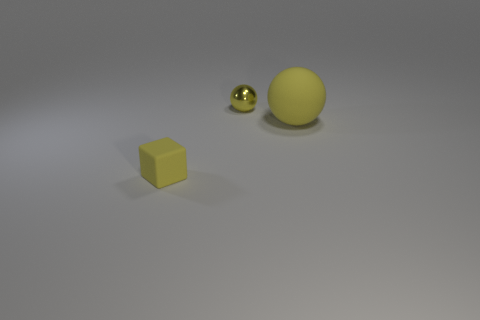What material is the small block that is the same color as the big rubber thing?
Your answer should be very brief. Rubber. What size is the matte sphere that is the same color as the tiny matte block?
Offer a terse response. Large. Is there a tiny yellow object that is to the right of the thing that is on the left side of the tiny sphere?
Provide a short and direct response. Yes. How many things are yellow things right of the matte block or tiny yellow things in front of the shiny thing?
Your response must be concise. 3. Is there any other thing that has the same color as the shiny sphere?
Ensure brevity in your answer.  Yes. There is a rubber object on the right side of the ball that is to the left of the rubber object behind the small matte thing; what color is it?
Ensure brevity in your answer.  Yellow. There is a yellow object that is to the right of the tiny object behind the small block; what is its size?
Give a very brief answer. Large. What material is the thing that is both on the left side of the big rubber sphere and behind the yellow matte cube?
Give a very brief answer. Metal. Do the yellow metallic object and the ball right of the yellow shiny sphere have the same size?
Your answer should be very brief. No. Are there any big yellow objects?
Give a very brief answer. Yes. 